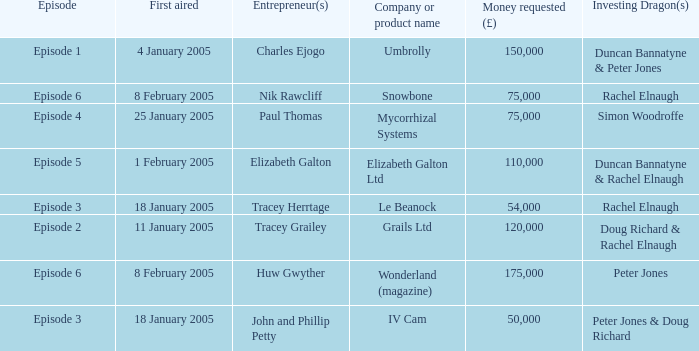What is the average money requested in the episode first aired on 18 January 2005 by the company/product name IV Cam 50000.0. 